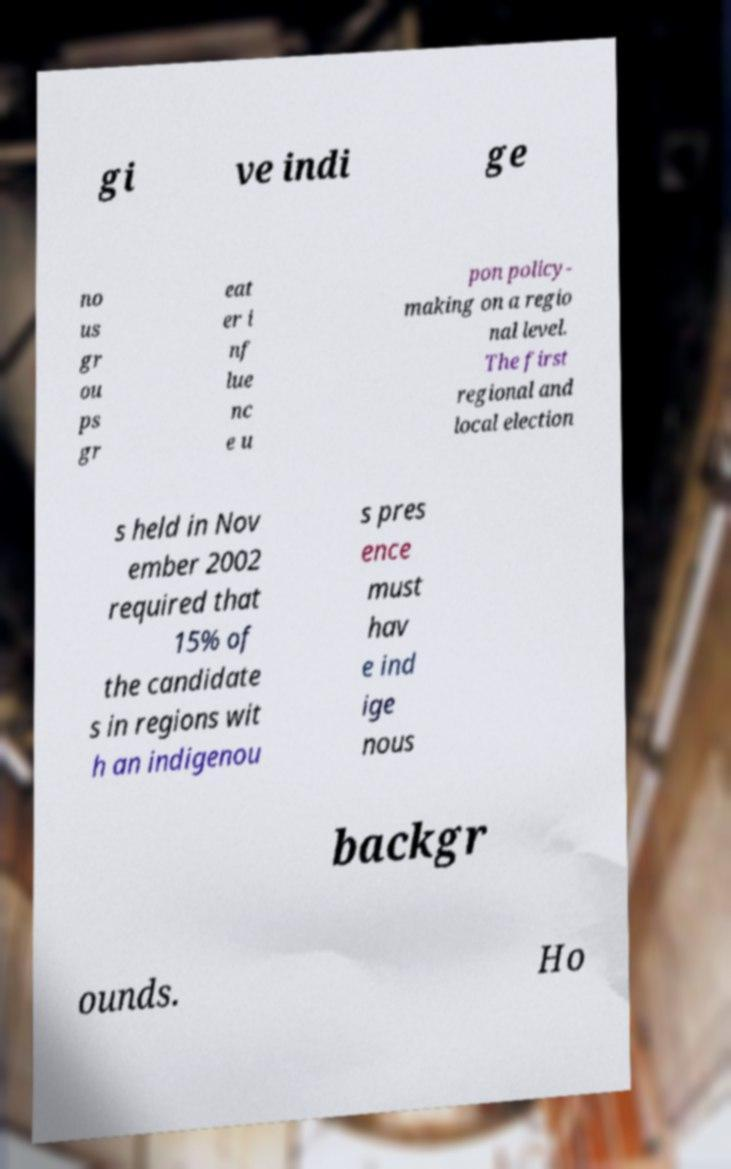Could you extract and type out the text from this image? gi ve indi ge no us gr ou ps gr eat er i nf lue nc e u pon policy- making on a regio nal level. The first regional and local election s held in Nov ember 2002 required that 15% of the candidate s in regions wit h an indigenou s pres ence must hav e ind ige nous backgr ounds. Ho 